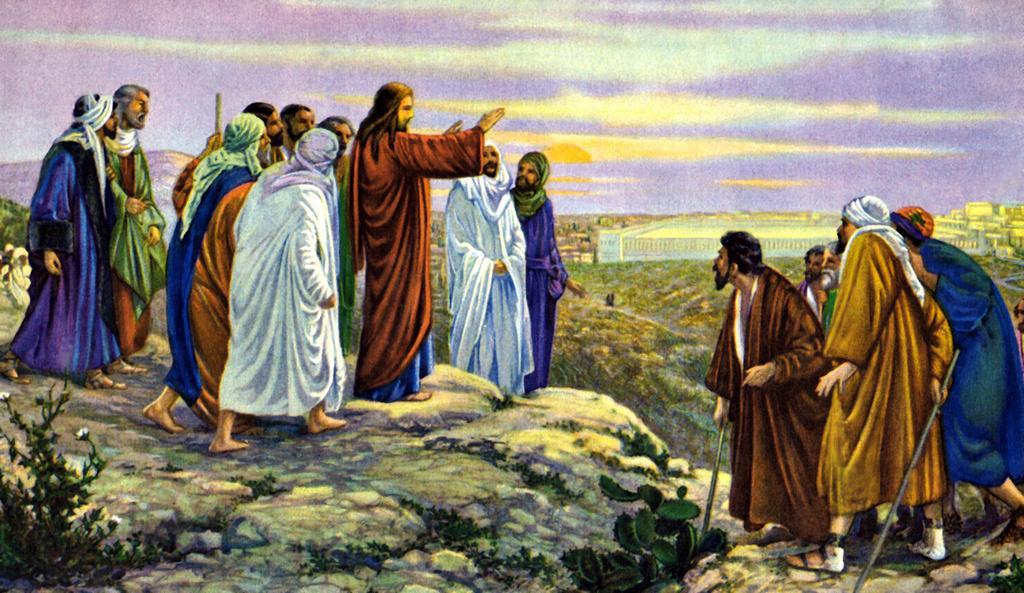Describe this image in one or two sentences. In this image we can see a painting picture of few people standing on the ground, some of them are holding sticks, there are few plants, buildings and the sky in the background. 